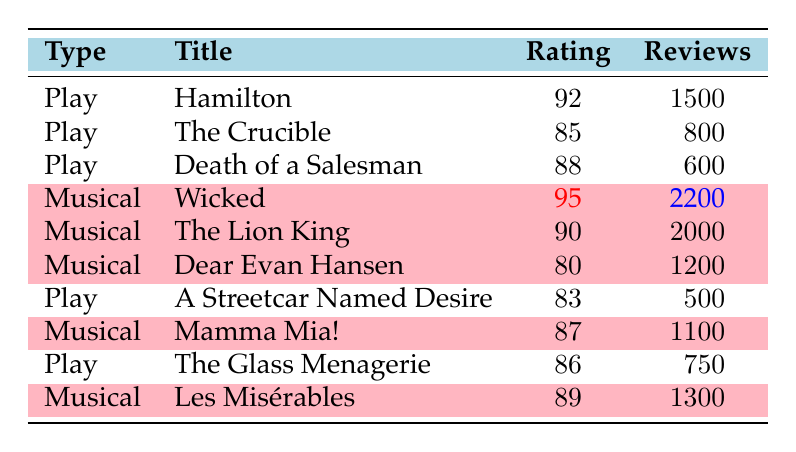What is the highest customer satisfaction rating among plays? The ratings for plays listed in the table are: Hamilton (92), The Crucible (85), Death of a Salesman (88), A Streetcar Named Desire (83), and The Glass Menagerie (86). The highest rating is from Hamilton at 92.
Answer: 92 Which musical has the lowest rating? The ratings for musicals are: Wicked (95), The Lion King (90), Dear Evan Hansen (80), Mamma Mia! (87), and Les Misérables (89). The lowest rating is from Dear Evan Hansen at 80.
Answer: 80 What is the total number of reviews for plays? The number of reviews for plays are: Hamilton (1500), The Crucible (800), Death of a Salesman (600), A Streetcar Named Desire (500), and The Glass Menagerie (750). Adding these gives: 1500 + 800 + 600 + 500 + 750 = 4150.
Answer: 4150 How many musicals received ratings of 85 or higher? The ratings of musicals are: Wicked (95), The Lion King (90), Dear Evan Hansen (80), Mamma Mia! (87), and Les Misérables (89). The ratings of 85 or higher are Wicked, The Lion King, Mamma Mia!, and Les Misérables, totaling 4 musicals.
Answer: 4 What is the average rating of plays? The ratings for plays are: Hamilton (92), The Crucible (85), Death of a Salesman (88), A Streetcar Named Desire (83), and The Glass Menagerie (86). To find the average: (92 + 85 + 88 + 83 + 86) / 5 = 86.8.
Answer: 86.8 Is the average customer satisfaction rating for musicals higher than that for plays? The average rating for plays is 86.8 and for musicals it is calculated as follows: (95 + 90 + 80 + 87 + 89) / 5 = 86.2. Since 86.8 (plays) is greater than 86.2 (musicals), the statement is true.
Answer: Yes What is the difference in total reviews between the musicals and plays? Total reviews for plays is 4150 and for musicals: Wicked (2200), The Lion King (2000), Dear Evan Hansen (1200), Mamma Mia! (1100), and Les Misérables (1300) which sums to: 2200 + 2000 + 1200 + 1100 + 1300 = 8900. The difference is 8900 - 4150 = 4750.
Answer: 4750 Which type of performance (play or musical) received the most reviews overall? The total reviews for plays is 4150 and for musicals is 8900. Since 8900 (musicals) is greater than 4150 (plays), musicals received the most reviews overall.
Answer: Musicals 